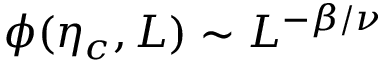<formula> <loc_0><loc_0><loc_500><loc_500>\phi ( \eta _ { c } , L ) \sim L ^ { - \beta / \nu }</formula> 